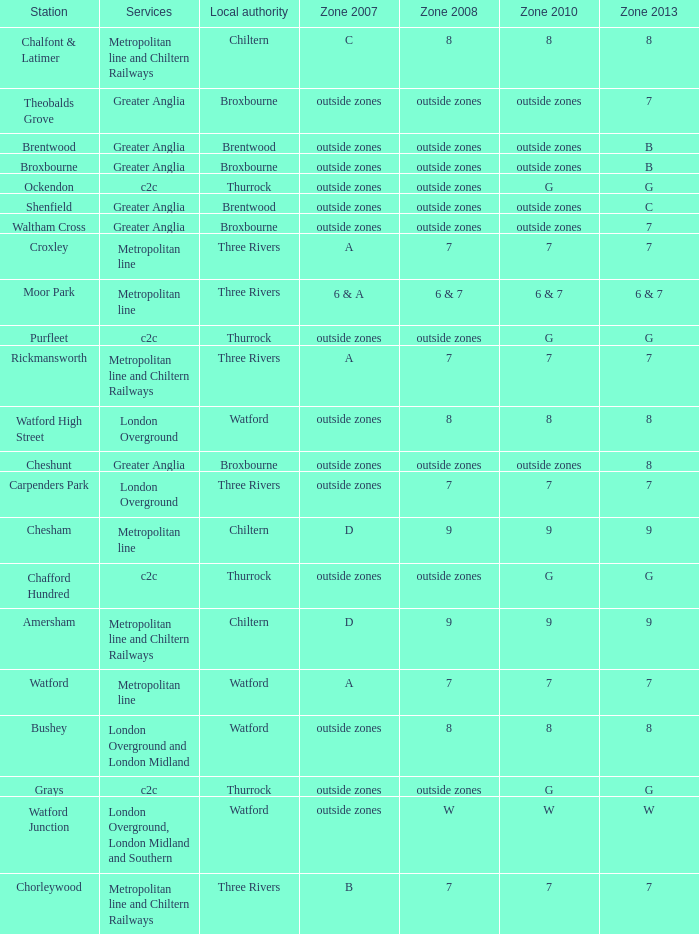Which Zone 2008 has Services of greater anglia, and a Station of cheshunt? Outside zones. 